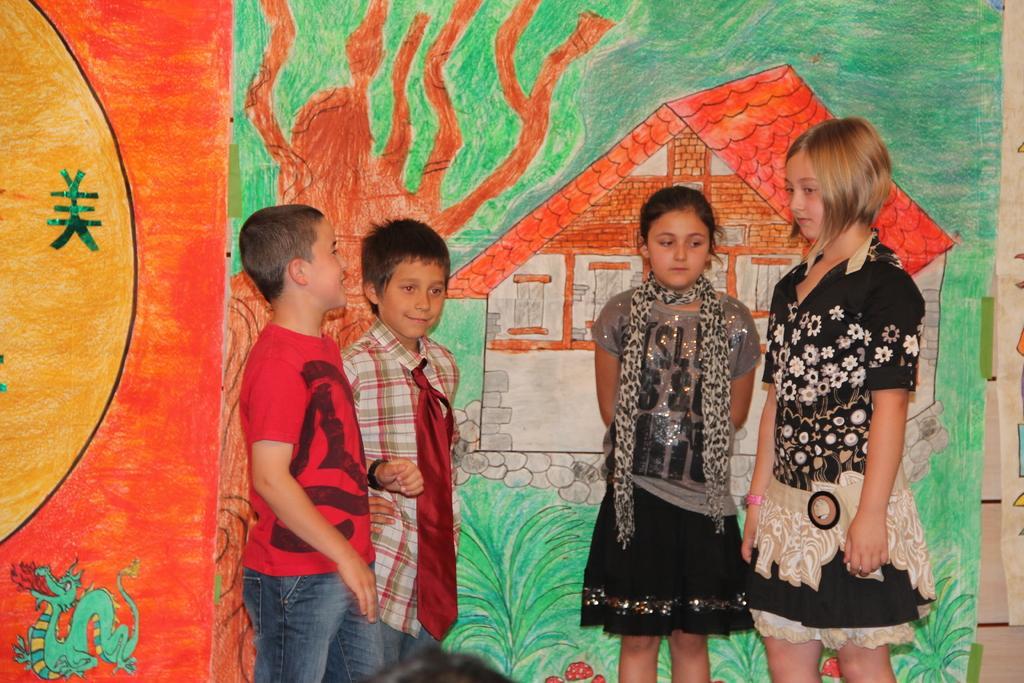How would you summarize this image in a sentence or two? In this image we can see a group of children standing. On the backside we can see the drawing of a house, the sun, plants, tree and an animal. 